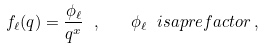<formula> <loc_0><loc_0><loc_500><loc_500>f _ { \ell } ( q ) = \frac { \phi _ { \ell } } { q ^ { x } } \ , \quad \phi _ { \ell } \ i s a p r e f a c t o r \, ,</formula> 